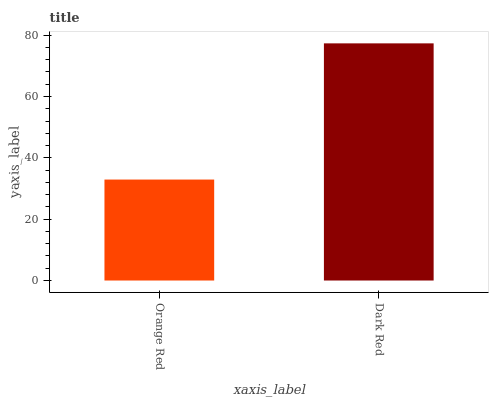Is Dark Red the minimum?
Answer yes or no. No. Is Dark Red greater than Orange Red?
Answer yes or no. Yes. Is Orange Red less than Dark Red?
Answer yes or no. Yes. Is Orange Red greater than Dark Red?
Answer yes or no. No. Is Dark Red less than Orange Red?
Answer yes or no. No. Is Dark Red the high median?
Answer yes or no. Yes. Is Orange Red the low median?
Answer yes or no. Yes. Is Orange Red the high median?
Answer yes or no. No. Is Dark Red the low median?
Answer yes or no. No. 